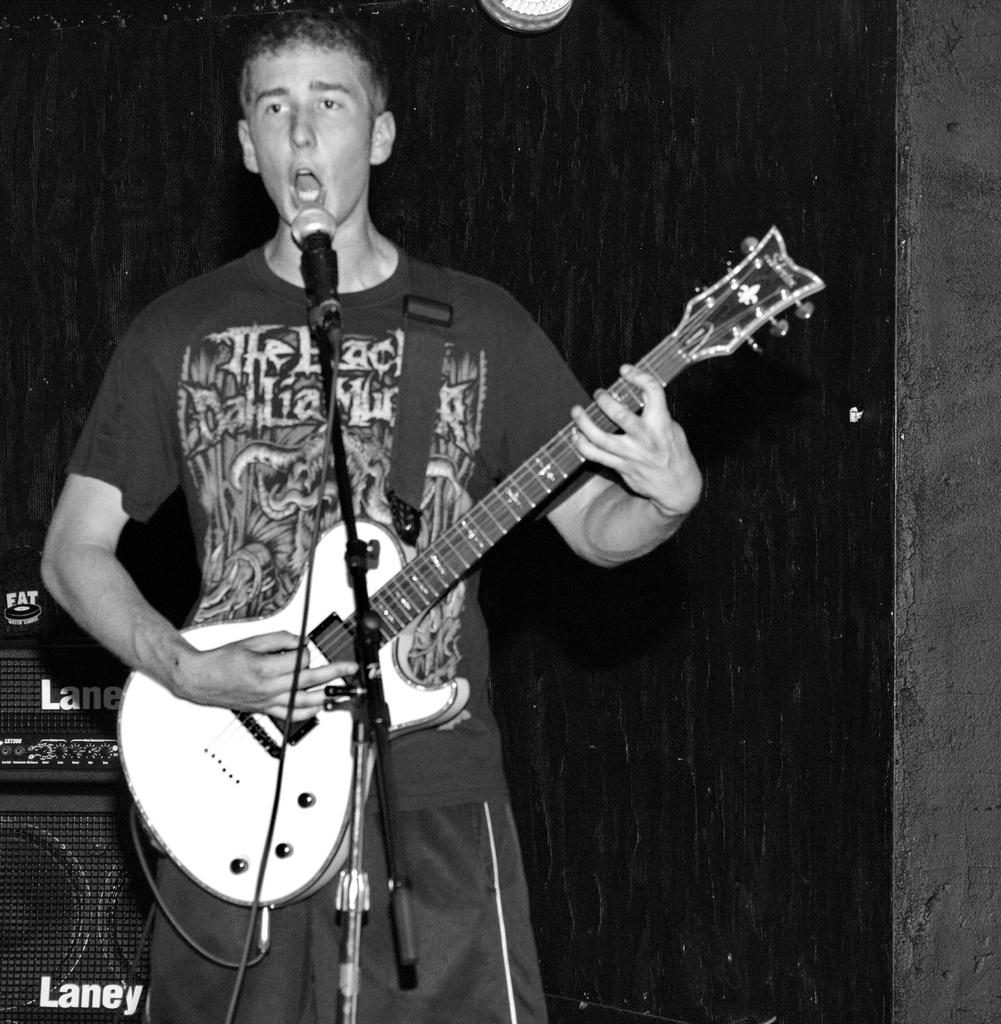What is the person in the image doing? The person is playing a guitar and singing. What is the person wearing in the image? The person is wearing a black shirt. What object is in front of the person? There is a microphone in front of the person. What objects are behind the person? There are speakers behind the person. What is the color of the background in the image? The background is black in color. How does the person use the whip in the image? There is no whip present in the image. What type of answer does the person provide when asked a question in the image? There is no indication in the image that the person is answering a question, so it cannot be determined from the picture. 